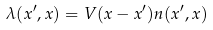Convert formula to latex. <formula><loc_0><loc_0><loc_500><loc_500>\lambda ( { x } ^ { \prime } , { x } ) = V ( { x } - { x } ^ { \prime } ) n ( { x } ^ { \prime } , { x } )</formula> 